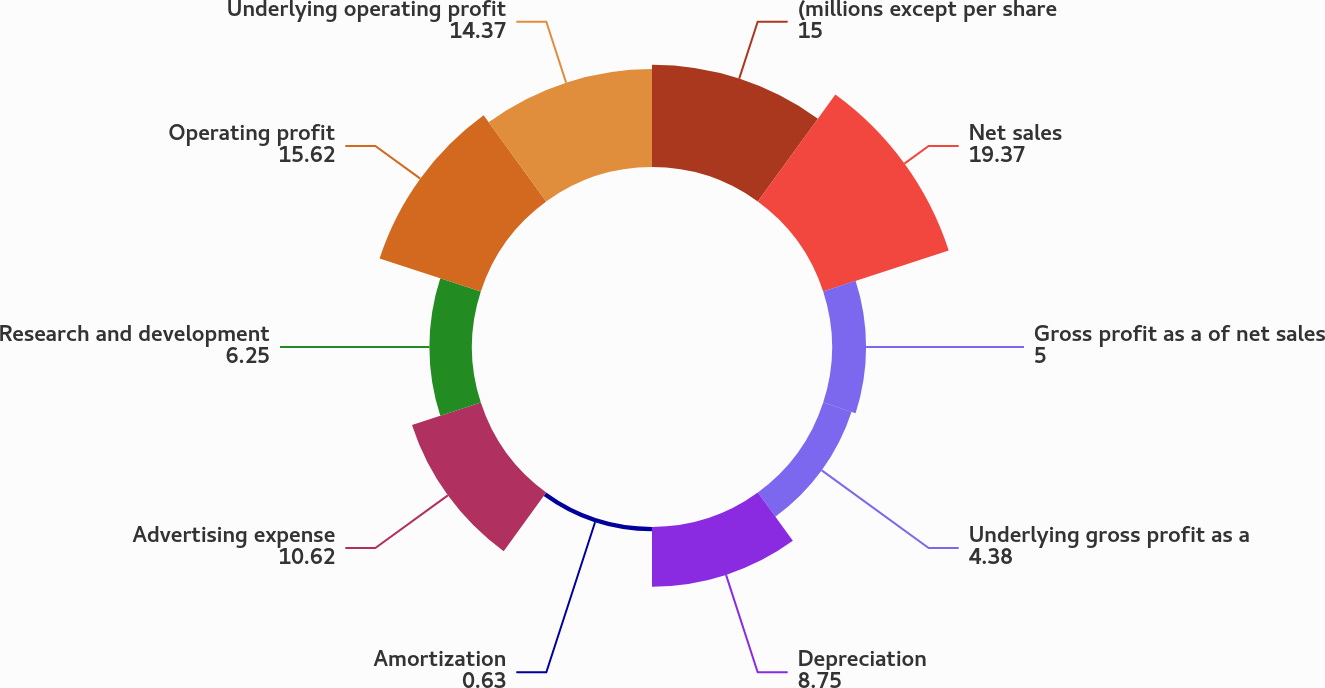<chart> <loc_0><loc_0><loc_500><loc_500><pie_chart><fcel>(millions except per share<fcel>Net sales<fcel>Gross profit as a of net sales<fcel>Underlying gross profit as a<fcel>Depreciation<fcel>Amortization<fcel>Advertising expense<fcel>Research and development<fcel>Operating profit<fcel>Underlying operating profit<nl><fcel>15.0%<fcel>19.37%<fcel>5.0%<fcel>4.38%<fcel>8.75%<fcel>0.63%<fcel>10.62%<fcel>6.25%<fcel>15.62%<fcel>14.37%<nl></chart> 